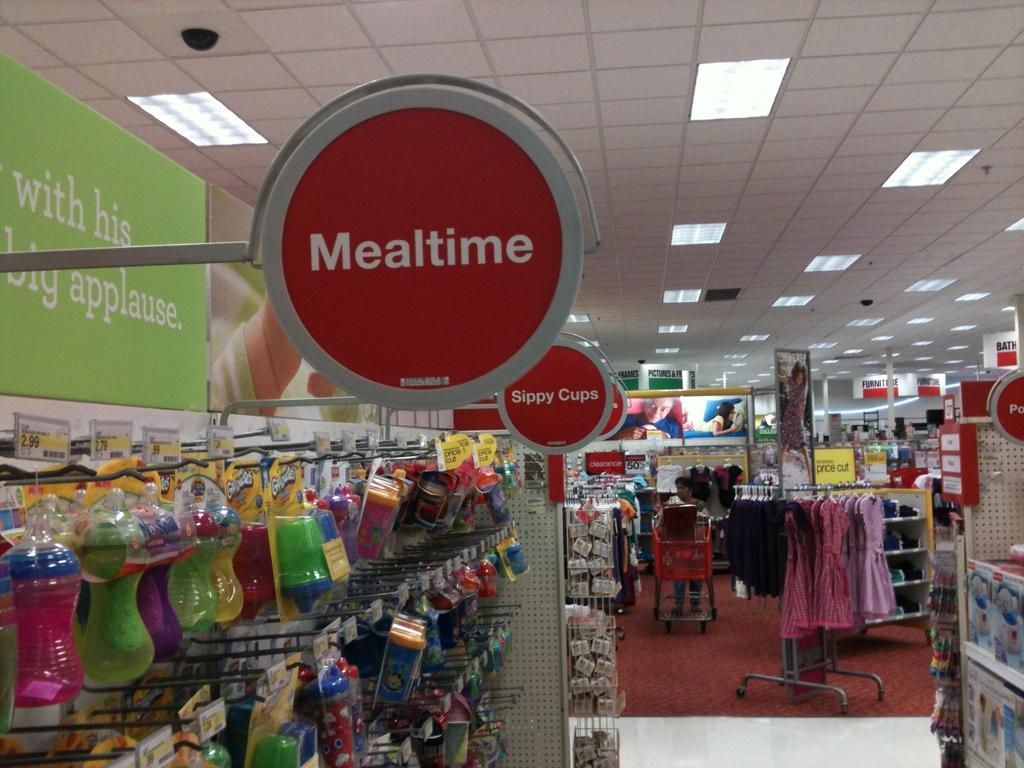Provide a one-sentence caption for the provided image. A sign in a store displaying the word MEALTIME. 